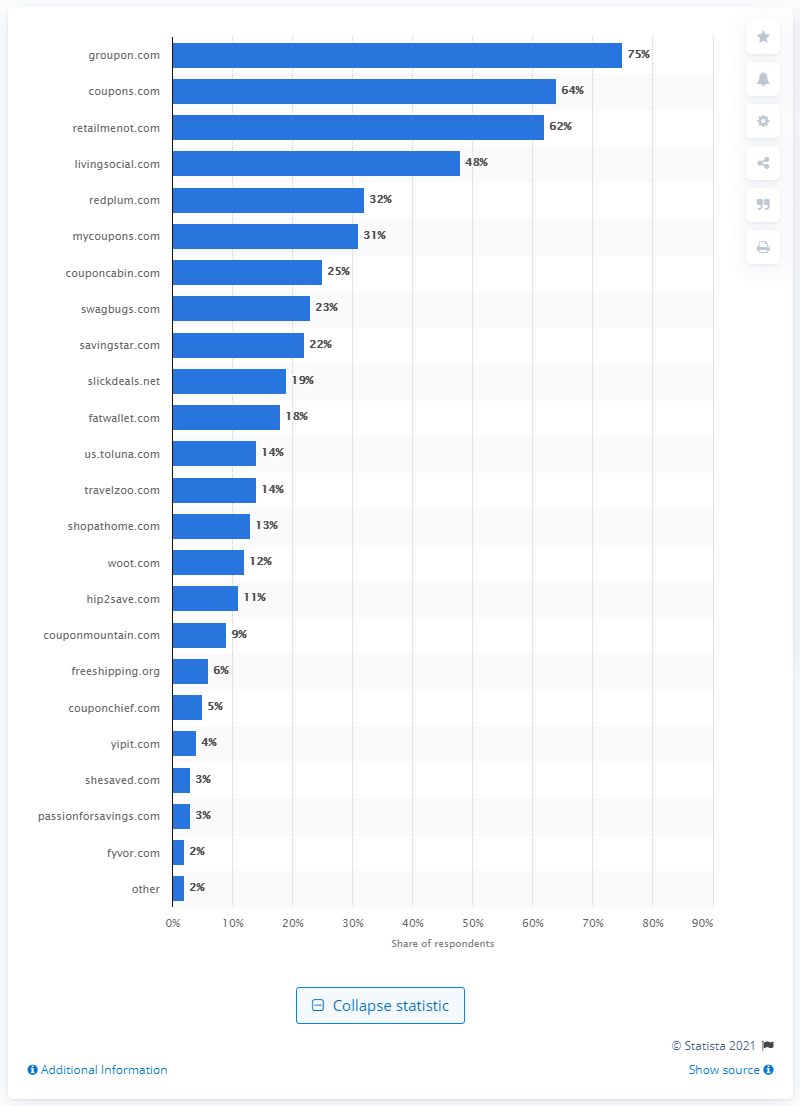Indicate a few pertinent items in this graphic. According to the survey results, 75% of the respondents stated that they were aware of Groupon.com. 